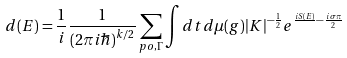<formula> <loc_0><loc_0><loc_500><loc_500>d ( E ) = \frac { 1 } { i } \frac { 1 } { ( 2 \pi i \hbar { ) } ^ { k / 2 } } \sum _ { p o , \Gamma } \int d t d \mu ( g ) | K | ^ { - \frac { 1 } { 2 } } e ^ { \frac { i S ( E ) } { } - \frac { i \sigma \pi } { 2 } }</formula> 